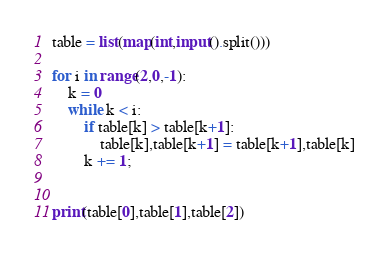Convert code to text. <code><loc_0><loc_0><loc_500><loc_500><_Python_>table = list(map(int,input().split()))

for i in range(2,0,-1):
    k = 0
    while k < i:
        if table[k] > table[k+1]:
            table[k],table[k+1] = table[k+1],table[k]
        k += 1;


print(table[0],table[1],table[2])
</code> 